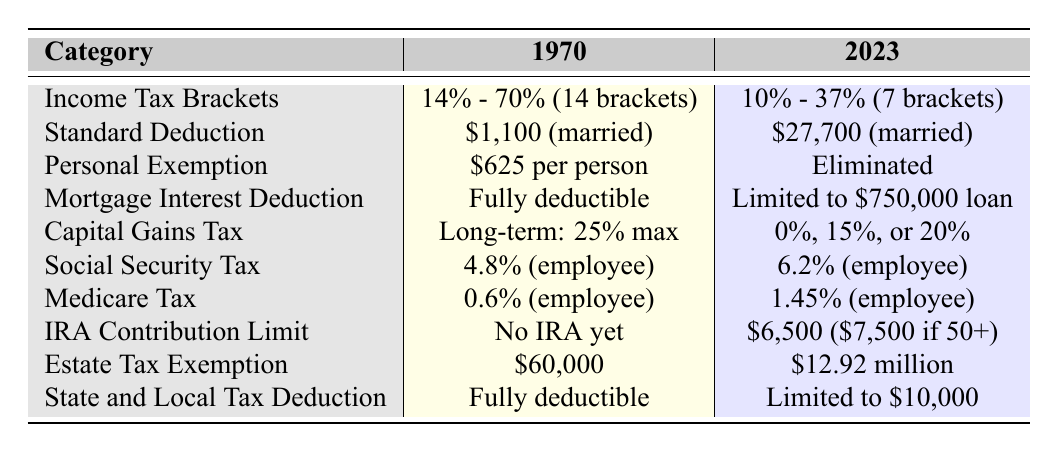What was the maximum personal income tax rate in 1970? The table shows that the maximum income tax rate in 1970 was 70%.
Answer: 70% What is the difference in standard deduction for married couples between 1970 and 2023? In 1970, the standard deduction for married couples was $1,100, while in 2023 it is $27,700. The difference is $27,700 - $1,100 = $26,600.
Answer: $26,600 Is the personal exemption still available in 2023? The table states that the personal exemption was eliminated in 2023.
Answer: No What is the maximum capital gains tax rate in both years? In 1970, the maximum long-term capital gains tax rate was 25%, while in 2023 it is either 0%, 15%, or 20%. The maximum rate in 2023 is 20%.
Answer: 25% in 1970, 20% in 2023 How much more can a married couple contribute to an IRA in 2023 compared to having no IRA option in 1970? There was no IRA allowed in 1970, giving a contribution limit of $0. In 2023, the limit for those under 50 is $6,500, so the difference is $6,500 - $0 = $6,500.
Answer: $6,500 Which tax deduction related to mortgage interest changed from fully deductible to having a limit, and what is that limit? The mortgage interest deduction changed from fully deductible in 1970 to being limited to a $750,000 loan in 2023.
Answer: Limited to $750,000 loan What was the estate tax exemption in 1970 compared to 2023? In 1970, the estate tax exemption was $60,000, while in 2023 it increased to $12.92 million. The difference is significant, showing a large increase over the years.
Answer: $60,000 in 1970, $12.92 million in 2023 Has the Social Security tax rate increased or decreased from 1970 to 2023? The Social Security tax rate was 4.8% in 1970 and increased to 6.2% in 2023, indicating an increase.
Answer: Increased What is the total number of tax brackets in 1970 and how does it compare to 2023? 1970 had 14 tax brackets (14% - 70%), while 2023 has 7 brackets (10% - 37%), which is a reduction of 7 brackets.
Answer: 14 in 1970, 7 in 2023 How much has the State and Local Tax Deduction changed from 1970 to 2023? In 1970, the deduction was fully deductible, while in 2023 it is limited to $10,000. This represents a significant change in policy.
Answer: Fully deductible in 1970, limited to $10,000 in 2023 